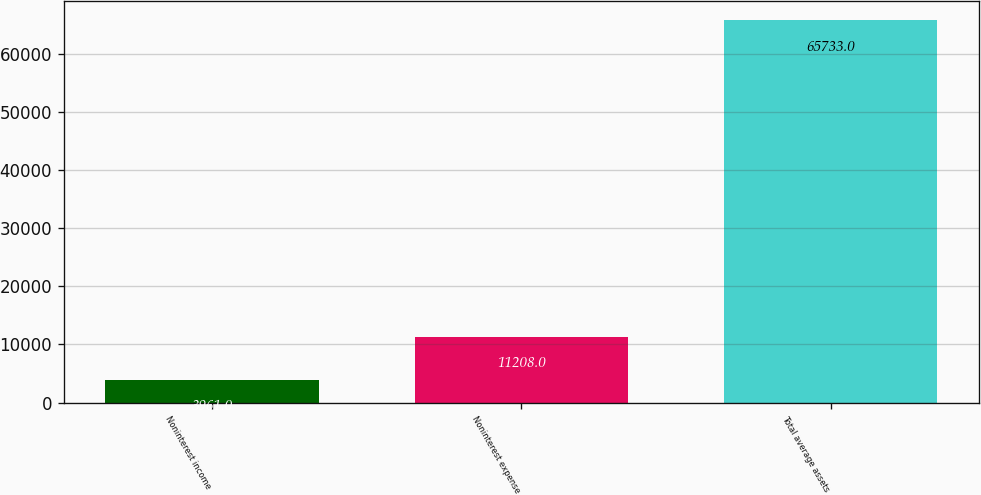Convert chart. <chart><loc_0><loc_0><loc_500><loc_500><bar_chart><fcel>Noninterest income<fcel>Noninterest expense<fcel>Total average assets<nl><fcel>3961<fcel>11208<fcel>65733<nl></chart> 